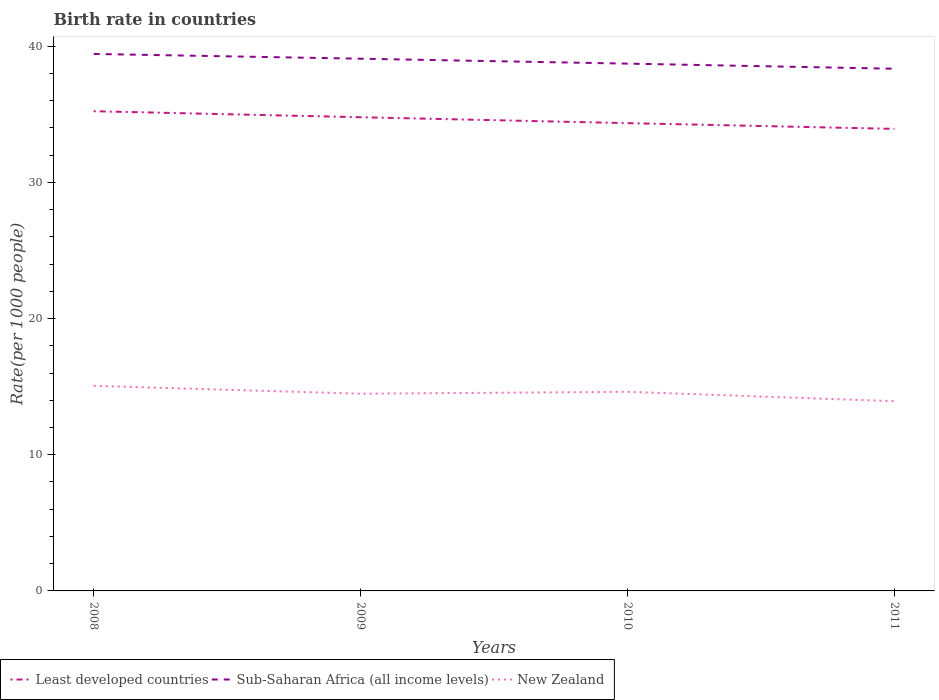Across all years, what is the maximum birth rate in New Zealand?
Give a very brief answer. 13.93. What is the total birth rate in New Zealand in the graph?
Make the answer very short. 1.13. What is the difference between the highest and the second highest birth rate in Sub-Saharan Africa (all income levels)?
Provide a short and direct response. 1.09. What is the difference between the highest and the lowest birth rate in Least developed countries?
Provide a short and direct response. 2. How many lines are there?
Your response must be concise. 3. What is the difference between two consecutive major ticks on the Y-axis?
Give a very brief answer. 10. Are the values on the major ticks of Y-axis written in scientific E-notation?
Offer a terse response. No. Does the graph contain any zero values?
Offer a very short reply. No. How many legend labels are there?
Your response must be concise. 3. What is the title of the graph?
Offer a very short reply. Birth rate in countries. Does "Mozambique" appear as one of the legend labels in the graph?
Provide a short and direct response. No. What is the label or title of the Y-axis?
Give a very brief answer. Rate(per 1000 people). What is the Rate(per 1000 people) in Least developed countries in 2008?
Make the answer very short. 35.22. What is the Rate(per 1000 people) in Sub-Saharan Africa (all income levels) in 2008?
Keep it short and to the point. 39.43. What is the Rate(per 1000 people) in New Zealand in 2008?
Your response must be concise. 15.06. What is the Rate(per 1000 people) in Least developed countries in 2009?
Your answer should be very brief. 34.78. What is the Rate(per 1000 people) in Sub-Saharan Africa (all income levels) in 2009?
Keep it short and to the point. 39.08. What is the Rate(per 1000 people) of New Zealand in 2009?
Your answer should be very brief. 14.48. What is the Rate(per 1000 people) of Least developed countries in 2010?
Provide a succinct answer. 34.35. What is the Rate(per 1000 people) in Sub-Saharan Africa (all income levels) in 2010?
Give a very brief answer. 38.72. What is the Rate(per 1000 people) of New Zealand in 2010?
Your answer should be compact. 14.62. What is the Rate(per 1000 people) of Least developed countries in 2011?
Make the answer very short. 33.93. What is the Rate(per 1000 people) in Sub-Saharan Africa (all income levels) in 2011?
Ensure brevity in your answer.  38.34. What is the Rate(per 1000 people) of New Zealand in 2011?
Provide a succinct answer. 13.93. Across all years, what is the maximum Rate(per 1000 people) in Least developed countries?
Make the answer very short. 35.22. Across all years, what is the maximum Rate(per 1000 people) of Sub-Saharan Africa (all income levels)?
Offer a terse response. 39.43. Across all years, what is the maximum Rate(per 1000 people) of New Zealand?
Ensure brevity in your answer.  15.06. Across all years, what is the minimum Rate(per 1000 people) in Least developed countries?
Provide a short and direct response. 33.93. Across all years, what is the minimum Rate(per 1000 people) in Sub-Saharan Africa (all income levels)?
Your answer should be compact. 38.34. Across all years, what is the minimum Rate(per 1000 people) in New Zealand?
Your answer should be compact. 13.93. What is the total Rate(per 1000 people) in Least developed countries in the graph?
Give a very brief answer. 138.28. What is the total Rate(per 1000 people) of Sub-Saharan Africa (all income levels) in the graph?
Provide a succinct answer. 155.57. What is the total Rate(per 1000 people) of New Zealand in the graph?
Ensure brevity in your answer.  58.09. What is the difference between the Rate(per 1000 people) of Least developed countries in 2008 and that in 2009?
Your answer should be very brief. 0.44. What is the difference between the Rate(per 1000 people) of Sub-Saharan Africa (all income levels) in 2008 and that in 2009?
Offer a terse response. 0.35. What is the difference between the Rate(per 1000 people) of New Zealand in 2008 and that in 2009?
Make the answer very short. 0.58. What is the difference between the Rate(per 1000 people) of Least developed countries in 2008 and that in 2010?
Keep it short and to the point. 0.88. What is the difference between the Rate(per 1000 people) in Sub-Saharan Africa (all income levels) in 2008 and that in 2010?
Offer a very short reply. 0.71. What is the difference between the Rate(per 1000 people) of New Zealand in 2008 and that in 2010?
Your answer should be compact. 0.44. What is the difference between the Rate(per 1000 people) of Least developed countries in 2008 and that in 2011?
Your response must be concise. 1.3. What is the difference between the Rate(per 1000 people) of Sub-Saharan Africa (all income levels) in 2008 and that in 2011?
Your answer should be very brief. 1.09. What is the difference between the Rate(per 1000 people) in New Zealand in 2008 and that in 2011?
Provide a succinct answer. 1.13. What is the difference between the Rate(per 1000 people) of Least developed countries in 2009 and that in 2010?
Make the answer very short. 0.43. What is the difference between the Rate(per 1000 people) in Sub-Saharan Africa (all income levels) in 2009 and that in 2010?
Offer a terse response. 0.36. What is the difference between the Rate(per 1000 people) of New Zealand in 2009 and that in 2010?
Your response must be concise. -0.14. What is the difference between the Rate(per 1000 people) in Least developed countries in 2009 and that in 2011?
Provide a succinct answer. 0.86. What is the difference between the Rate(per 1000 people) of Sub-Saharan Africa (all income levels) in 2009 and that in 2011?
Make the answer very short. 0.74. What is the difference between the Rate(per 1000 people) of New Zealand in 2009 and that in 2011?
Offer a very short reply. 0.55. What is the difference between the Rate(per 1000 people) of Least developed countries in 2010 and that in 2011?
Make the answer very short. 0.42. What is the difference between the Rate(per 1000 people) of Sub-Saharan Africa (all income levels) in 2010 and that in 2011?
Your answer should be compact. 0.38. What is the difference between the Rate(per 1000 people) in New Zealand in 2010 and that in 2011?
Offer a terse response. 0.69. What is the difference between the Rate(per 1000 people) of Least developed countries in 2008 and the Rate(per 1000 people) of Sub-Saharan Africa (all income levels) in 2009?
Make the answer very short. -3.86. What is the difference between the Rate(per 1000 people) in Least developed countries in 2008 and the Rate(per 1000 people) in New Zealand in 2009?
Keep it short and to the point. 20.74. What is the difference between the Rate(per 1000 people) in Sub-Saharan Africa (all income levels) in 2008 and the Rate(per 1000 people) in New Zealand in 2009?
Your answer should be very brief. 24.95. What is the difference between the Rate(per 1000 people) in Least developed countries in 2008 and the Rate(per 1000 people) in Sub-Saharan Africa (all income levels) in 2010?
Your response must be concise. -3.49. What is the difference between the Rate(per 1000 people) of Least developed countries in 2008 and the Rate(per 1000 people) of New Zealand in 2010?
Offer a very short reply. 20.6. What is the difference between the Rate(per 1000 people) in Sub-Saharan Africa (all income levels) in 2008 and the Rate(per 1000 people) in New Zealand in 2010?
Provide a succinct answer. 24.81. What is the difference between the Rate(per 1000 people) in Least developed countries in 2008 and the Rate(per 1000 people) in Sub-Saharan Africa (all income levels) in 2011?
Your answer should be very brief. -3.12. What is the difference between the Rate(per 1000 people) of Least developed countries in 2008 and the Rate(per 1000 people) of New Zealand in 2011?
Offer a very short reply. 21.29. What is the difference between the Rate(per 1000 people) of Sub-Saharan Africa (all income levels) in 2008 and the Rate(per 1000 people) of New Zealand in 2011?
Your answer should be very brief. 25.5. What is the difference between the Rate(per 1000 people) of Least developed countries in 2009 and the Rate(per 1000 people) of Sub-Saharan Africa (all income levels) in 2010?
Your answer should be very brief. -3.94. What is the difference between the Rate(per 1000 people) of Least developed countries in 2009 and the Rate(per 1000 people) of New Zealand in 2010?
Your response must be concise. 20.16. What is the difference between the Rate(per 1000 people) of Sub-Saharan Africa (all income levels) in 2009 and the Rate(per 1000 people) of New Zealand in 2010?
Provide a short and direct response. 24.46. What is the difference between the Rate(per 1000 people) in Least developed countries in 2009 and the Rate(per 1000 people) in Sub-Saharan Africa (all income levels) in 2011?
Offer a terse response. -3.56. What is the difference between the Rate(per 1000 people) in Least developed countries in 2009 and the Rate(per 1000 people) in New Zealand in 2011?
Provide a short and direct response. 20.85. What is the difference between the Rate(per 1000 people) in Sub-Saharan Africa (all income levels) in 2009 and the Rate(per 1000 people) in New Zealand in 2011?
Offer a very short reply. 25.15. What is the difference between the Rate(per 1000 people) of Least developed countries in 2010 and the Rate(per 1000 people) of Sub-Saharan Africa (all income levels) in 2011?
Your answer should be compact. -3.99. What is the difference between the Rate(per 1000 people) in Least developed countries in 2010 and the Rate(per 1000 people) in New Zealand in 2011?
Keep it short and to the point. 20.42. What is the difference between the Rate(per 1000 people) in Sub-Saharan Africa (all income levels) in 2010 and the Rate(per 1000 people) in New Zealand in 2011?
Your answer should be compact. 24.79. What is the average Rate(per 1000 people) in Least developed countries per year?
Offer a very short reply. 34.57. What is the average Rate(per 1000 people) of Sub-Saharan Africa (all income levels) per year?
Provide a short and direct response. 38.89. What is the average Rate(per 1000 people) of New Zealand per year?
Provide a succinct answer. 14.52. In the year 2008, what is the difference between the Rate(per 1000 people) in Least developed countries and Rate(per 1000 people) in Sub-Saharan Africa (all income levels)?
Provide a succinct answer. -4.21. In the year 2008, what is the difference between the Rate(per 1000 people) of Least developed countries and Rate(per 1000 people) of New Zealand?
Offer a very short reply. 20.16. In the year 2008, what is the difference between the Rate(per 1000 people) of Sub-Saharan Africa (all income levels) and Rate(per 1000 people) of New Zealand?
Keep it short and to the point. 24.37. In the year 2009, what is the difference between the Rate(per 1000 people) of Least developed countries and Rate(per 1000 people) of Sub-Saharan Africa (all income levels)?
Provide a succinct answer. -4.3. In the year 2009, what is the difference between the Rate(per 1000 people) of Least developed countries and Rate(per 1000 people) of New Zealand?
Keep it short and to the point. 20.3. In the year 2009, what is the difference between the Rate(per 1000 people) of Sub-Saharan Africa (all income levels) and Rate(per 1000 people) of New Zealand?
Provide a succinct answer. 24.6. In the year 2010, what is the difference between the Rate(per 1000 people) in Least developed countries and Rate(per 1000 people) in Sub-Saharan Africa (all income levels)?
Provide a succinct answer. -4.37. In the year 2010, what is the difference between the Rate(per 1000 people) in Least developed countries and Rate(per 1000 people) in New Zealand?
Your answer should be compact. 19.73. In the year 2010, what is the difference between the Rate(per 1000 people) in Sub-Saharan Africa (all income levels) and Rate(per 1000 people) in New Zealand?
Your response must be concise. 24.1. In the year 2011, what is the difference between the Rate(per 1000 people) in Least developed countries and Rate(per 1000 people) in Sub-Saharan Africa (all income levels)?
Your answer should be compact. -4.42. In the year 2011, what is the difference between the Rate(per 1000 people) in Least developed countries and Rate(per 1000 people) in New Zealand?
Make the answer very short. 20. In the year 2011, what is the difference between the Rate(per 1000 people) in Sub-Saharan Africa (all income levels) and Rate(per 1000 people) in New Zealand?
Provide a succinct answer. 24.41. What is the ratio of the Rate(per 1000 people) of Least developed countries in 2008 to that in 2009?
Provide a short and direct response. 1.01. What is the ratio of the Rate(per 1000 people) of New Zealand in 2008 to that in 2009?
Your answer should be very brief. 1.04. What is the ratio of the Rate(per 1000 people) in Least developed countries in 2008 to that in 2010?
Make the answer very short. 1.03. What is the ratio of the Rate(per 1000 people) in Sub-Saharan Africa (all income levels) in 2008 to that in 2010?
Your response must be concise. 1.02. What is the ratio of the Rate(per 1000 people) in New Zealand in 2008 to that in 2010?
Ensure brevity in your answer.  1.03. What is the ratio of the Rate(per 1000 people) of Least developed countries in 2008 to that in 2011?
Your response must be concise. 1.04. What is the ratio of the Rate(per 1000 people) of Sub-Saharan Africa (all income levels) in 2008 to that in 2011?
Your answer should be very brief. 1.03. What is the ratio of the Rate(per 1000 people) of New Zealand in 2008 to that in 2011?
Provide a short and direct response. 1.08. What is the ratio of the Rate(per 1000 people) in Least developed countries in 2009 to that in 2010?
Provide a short and direct response. 1.01. What is the ratio of the Rate(per 1000 people) in Sub-Saharan Africa (all income levels) in 2009 to that in 2010?
Make the answer very short. 1.01. What is the ratio of the Rate(per 1000 people) of Least developed countries in 2009 to that in 2011?
Provide a succinct answer. 1.03. What is the ratio of the Rate(per 1000 people) of Sub-Saharan Africa (all income levels) in 2009 to that in 2011?
Provide a succinct answer. 1.02. What is the ratio of the Rate(per 1000 people) in New Zealand in 2009 to that in 2011?
Ensure brevity in your answer.  1.04. What is the ratio of the Rate(per 1000 people) in Least developed countries in 2010 to that in 2011?
Make the answer very short. 1.01. What is the ratio of the Rate(per 1000 people) of Sub-Saharan Africa (all income levels) in 2010 to that in 2011?
Provide a succinct answer. 1.01. What is the ratio of the Rate(per 1000 people) in New Zealand in 2010 to that in 2011?
Your response must be concise. 1.05. What is the difference between the highest and the second highest Rate(per 1000 people) of Least developed countries?
Provide a short and direct response. 0.44. What is the difference between the highest and the second highest Rate(per 1000 people) of Sub-Saharan Africa (all income levels)?
Keep it short and to the point. 0.35. What is the difference between the highest and the second highest Rate(per 1000 people) of New Zealand?
Keep it short and to the point. 0.44. What is the difference between the highest and the lowest Rate(per 1000 people) in Least developed countries?
Your answer should be very brief. 1.3. What is the difference between the highest and the lowest Rate(per 1000 people) in Sub-Saharan Africa (all income levels)?
Provide a succinct answer. 1.09. What is the difference between the highest and the lowest Rate(per 1000 people) of New Zealand?
Your response must be concise. 1.13. 